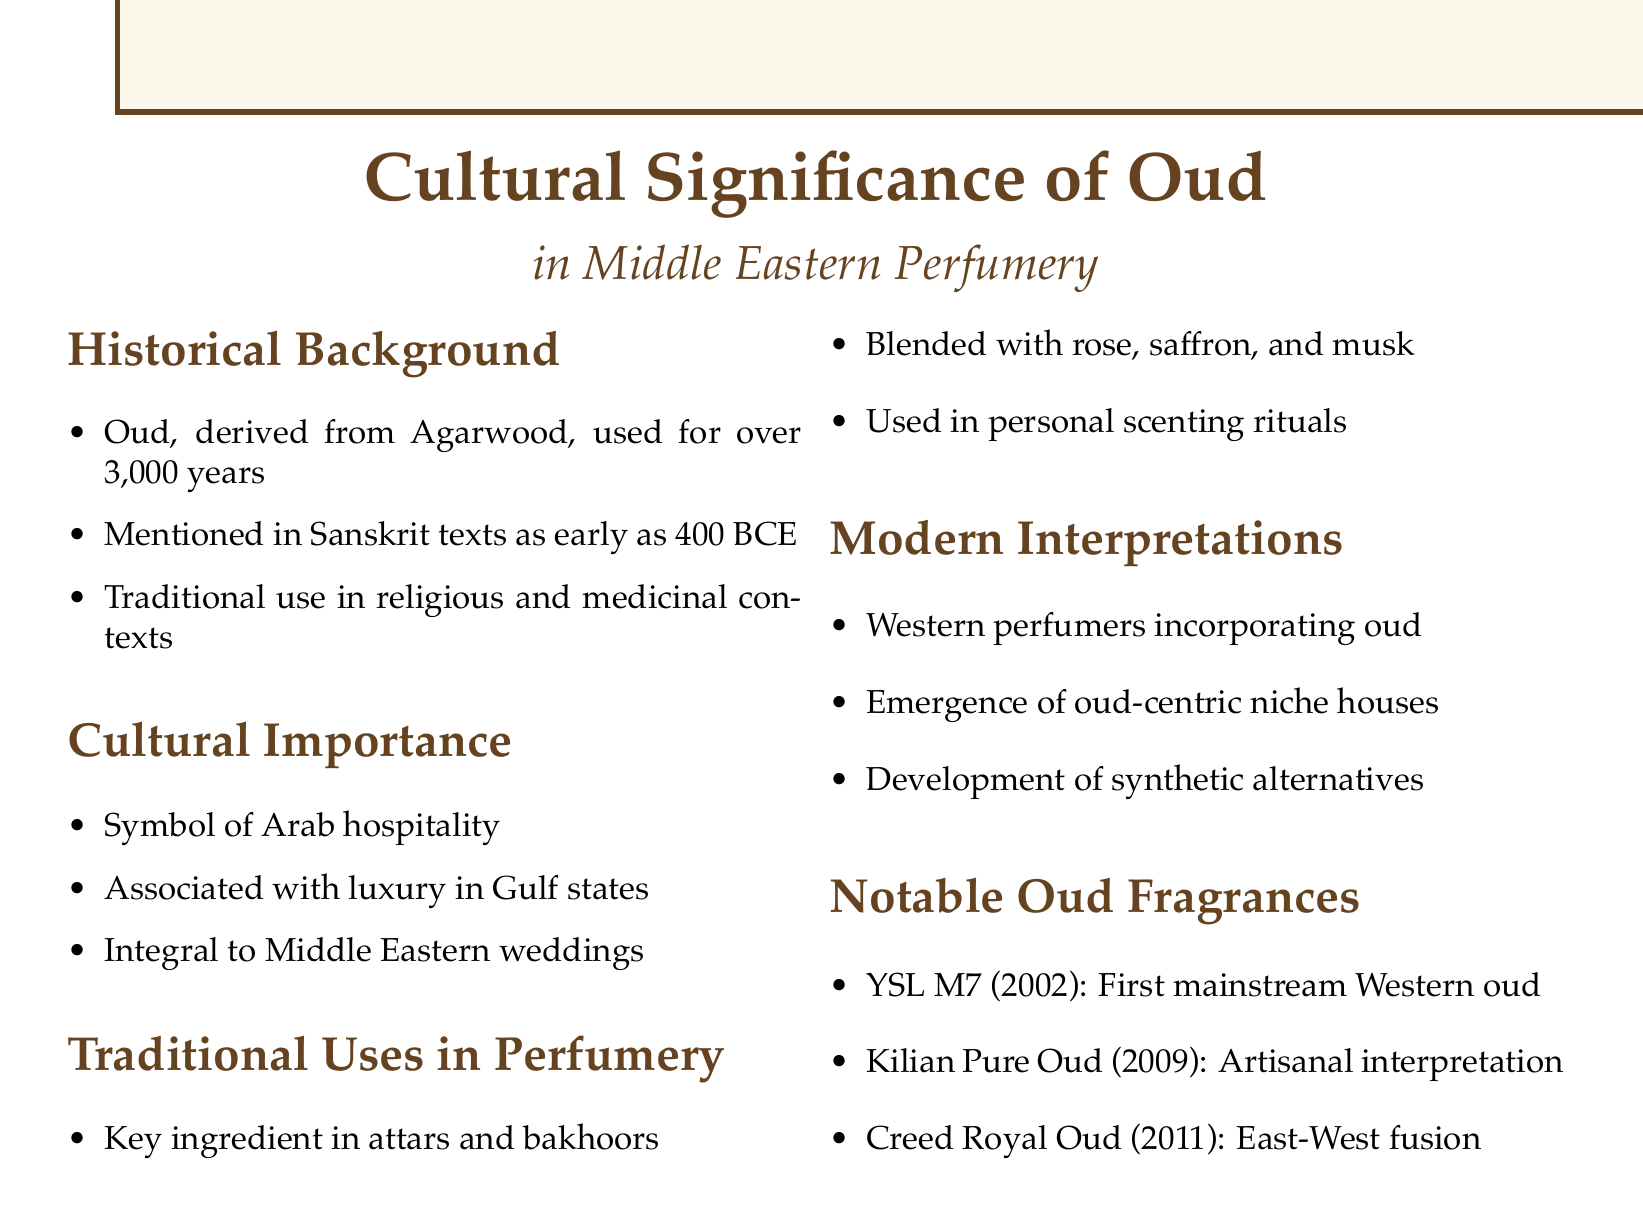What is oud derived from? Oud is derived from Agarwood, as mentioned in the historical background section.
Answer: Agarwood How long has oud been used in Middle Eastern perfumery? The historical background states that oud has been used for over 3,000 years.
Answer: Over 3,000 years Which texts mention oud as early as 400 BCE? The historical background points to ancient Sanskrit texts.
Answer: Sanskrit texts What is oud a symbol of in Arab culture? The cultural importance section states it is a symbol of hospitality.
Answer: Hospitality Which Western perfumer incorporated oud in luxury fragrances? The modern interpretations section mentions Francis Kurkdjian.
Answer: Francis Kurkdjian What key ingredient is blended with oud in traditional perfumes? The traditional uses section lists rose as a key ingredient blended with oud.
Answer: Rose What year was Yves Saint Laurent's M7 released? The notable oud fragrances section states that M7 was released in 2002.
Answer: 2002 What are synthetic oud alternatives developed due to? The modern interpretations section states they were developed due to sustainability concerns.
Answer: Sustainability concerns Which fragrance is an artisanal interpretation of traditional Middle Eastern oud? The notable oud fragrances section specifies Kilian - Pure Oud.
Answer: Kilian - Pure Oud What is integral to Middle Eastern wedding traditions? The cultural importance section mentions oud as an integral part of wedding traditions.
Answer: Oud 